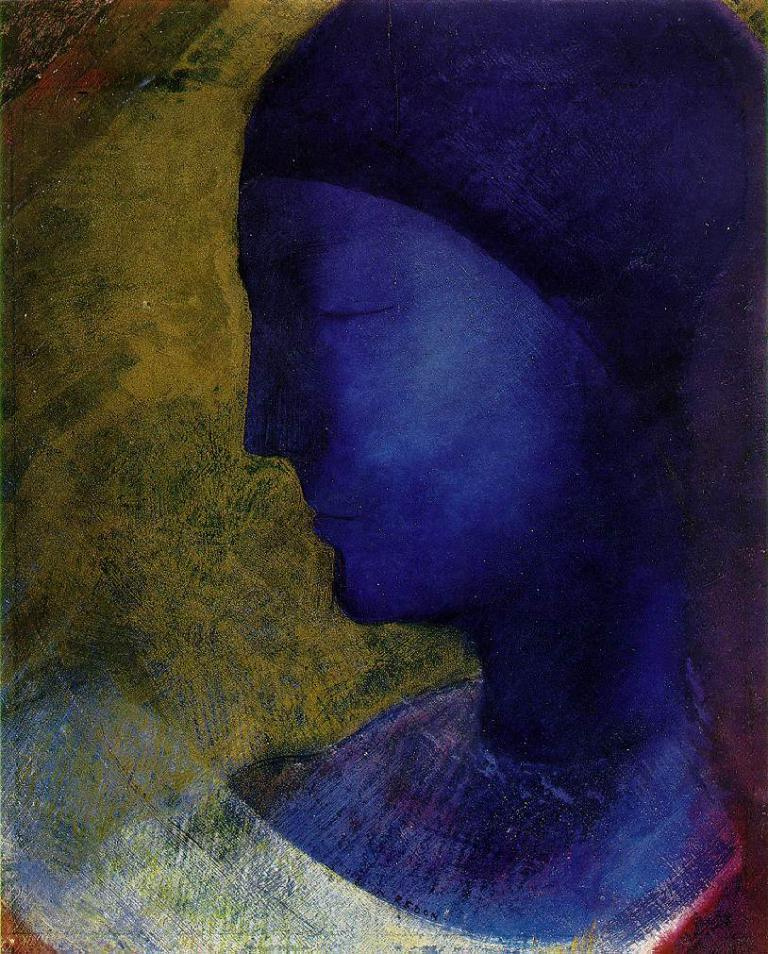What is the main subject of the image? There is a portrait of a lady in the image. Where is the portrait located in the image? The portrait is in the center of the image. What type of ball is being used for breakfast in the image? There is no ball or reference to breakfast in the image; it features a portrait of a lady. What color is the ink used to draw the portrait in the image? The image is a photograph, not a drawing, so there is no ink used in the creation of the portrait. 